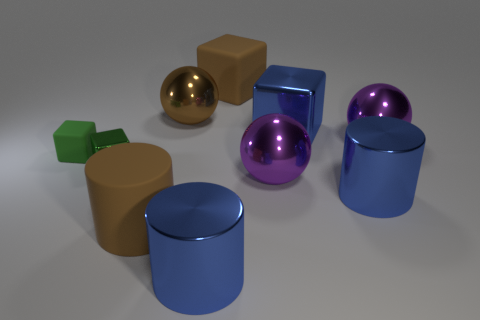Subtract 1 blocks. How many blocks are left? 3 Subtract all red spheres. Subtract all yellow blocks. How many spheres are left? 3 Subtract all blocks. How many objects are left? 6 Subtract 0 green balls. How many objects are left? 10 Subtract all large brown metal things. Subtract all big things. How many objects are left? 1 Add 2 large blue blocks. How many large blue blocks are left? 3 Add 4 brown things. How many brown things exist? 7 